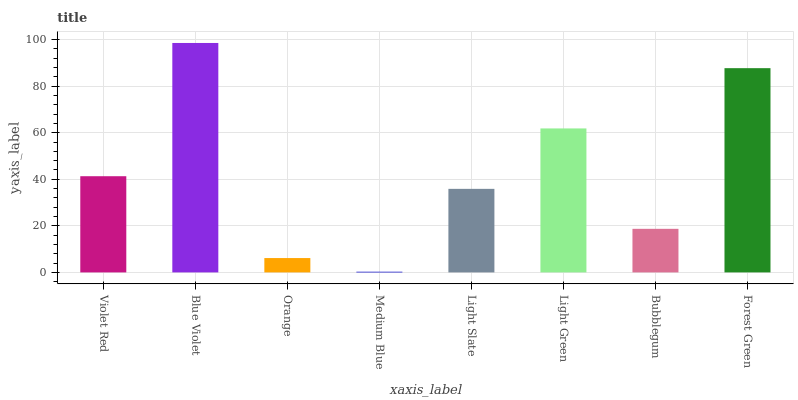Is Medium Blue the minimum?
Answer yes or no. Yes. Is Blue Violet the maximum?
Answer yes or no. Yes. Is Orange the minimum?
Answer yes or no. No. Is Orange the maximum?
Answer yes or no. No. Is Blue Violet greater than Orange?
Answer yes or no. Yes. Is Orange less than Blue Violet?
Answer yes or no. Yes. Is Orange greater than Blue Violet?
Answer yes or no. No. Is Blue Violet less than Orange?
Answer yes or no. No. Is Violet Red the high median?
Answer yes or no. Yes. Is Light Slate the low median?
Answer yes or no. Yes. Is Forest Green the high median?
Answer yes or no. No. Is Bubblegum the low median?
Answer yes or no. No. 